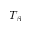<formula> <loc_0><loc_0><loc_500><loc_500>T _ { \beta }</formula> 